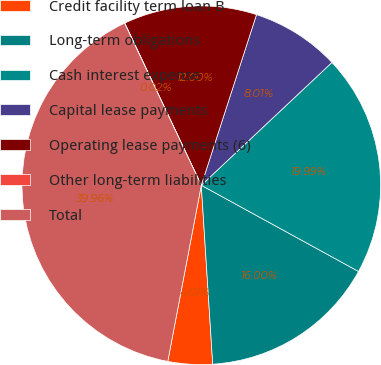Convert chart to OTSL. <chart><loc_0><loc_0><loc_500><loc_500><pie_chart><fcel>Credit facility term loan B<fcel>Long-term obligations<fcel>Cash interest expense<fcel>Capital lease payments<fcel>Operating lease payments (6)<fcel>Other long-term liabilities<fcel>Total<nl><fcel>4.01%<fcel>16.0%<fcel>19.99%<fcel>8.01%<fcel>12.0%<fcel>0.02%<fcel>39.96%<nl></chart> 